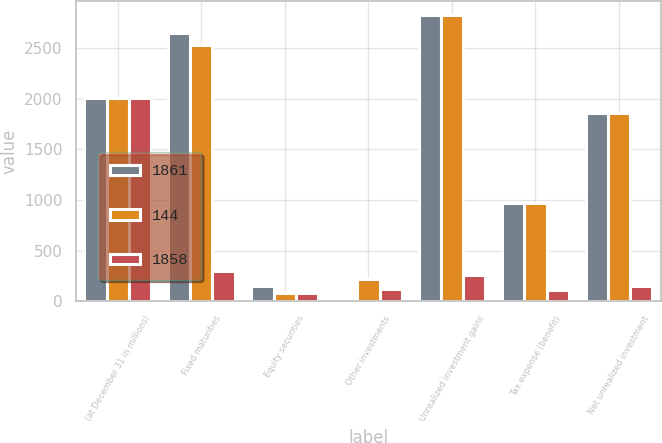Convert chart. <chart><loc_0><loc_0><loc_500><loc_500><stacked_bar_chart><ecel><fcel>(at December 31 in millions)<fcel>Fixed maturities<fcel>Equity securities<fcel>Other investments<fcel>Unrealized investment gains<fcel>Tax expense (benefit)<fcel>Net unrealized investment<nl><fcel>1861<fcel>2010<fcel>2650<fcel>147<fcel>28<fcel>2825<fcel>967<fcel>1858<nl><fcel>144<fcel>2009<fcel>2536<fcel>78<fcel>216<fcel>2830<fcel>969<fcel>1861<nl><fcel>1858<fcel>2008<fcel>294<fcel>82<fcel>123<fcel>253<fcel>109<fcel>144<nl></chart> 